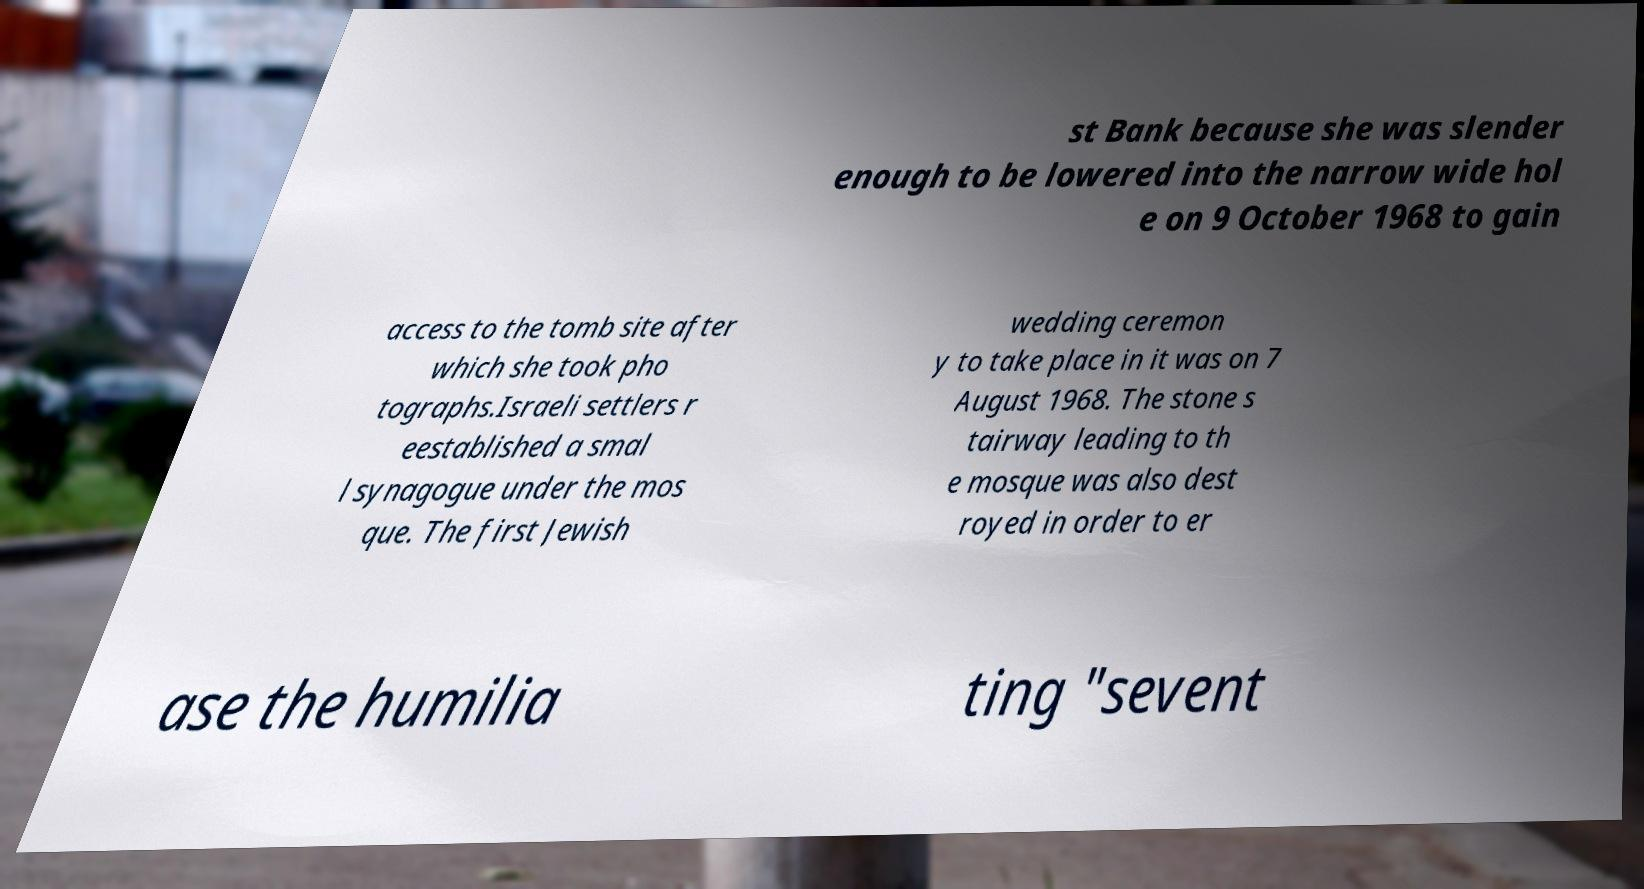Could you extract and type out the text from this image? st Bank because she was slender enough to be lowered into the narrow wide hol e on 9 October 1968 to gain access to the tomb site after which she took pho tographs.Israeli settlers r eestablished a smal l synagogue under the mos que. The first Jewish wedding ceremon y to take place in it was on 7 August 1968. The stone s tairway leading to th e mosque was also dest royed in order to er ase the humilia ting "sevent 